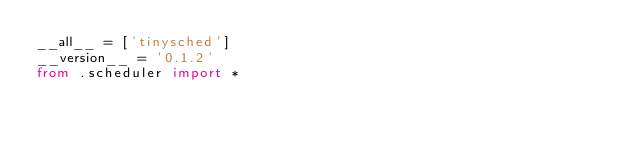<code> <loc_0><loc_0><loc_500><loc_500><_Python_>__all__ = ['tinysched']
__version__ = '0.1.2'
from .scheduler import *
</code> 